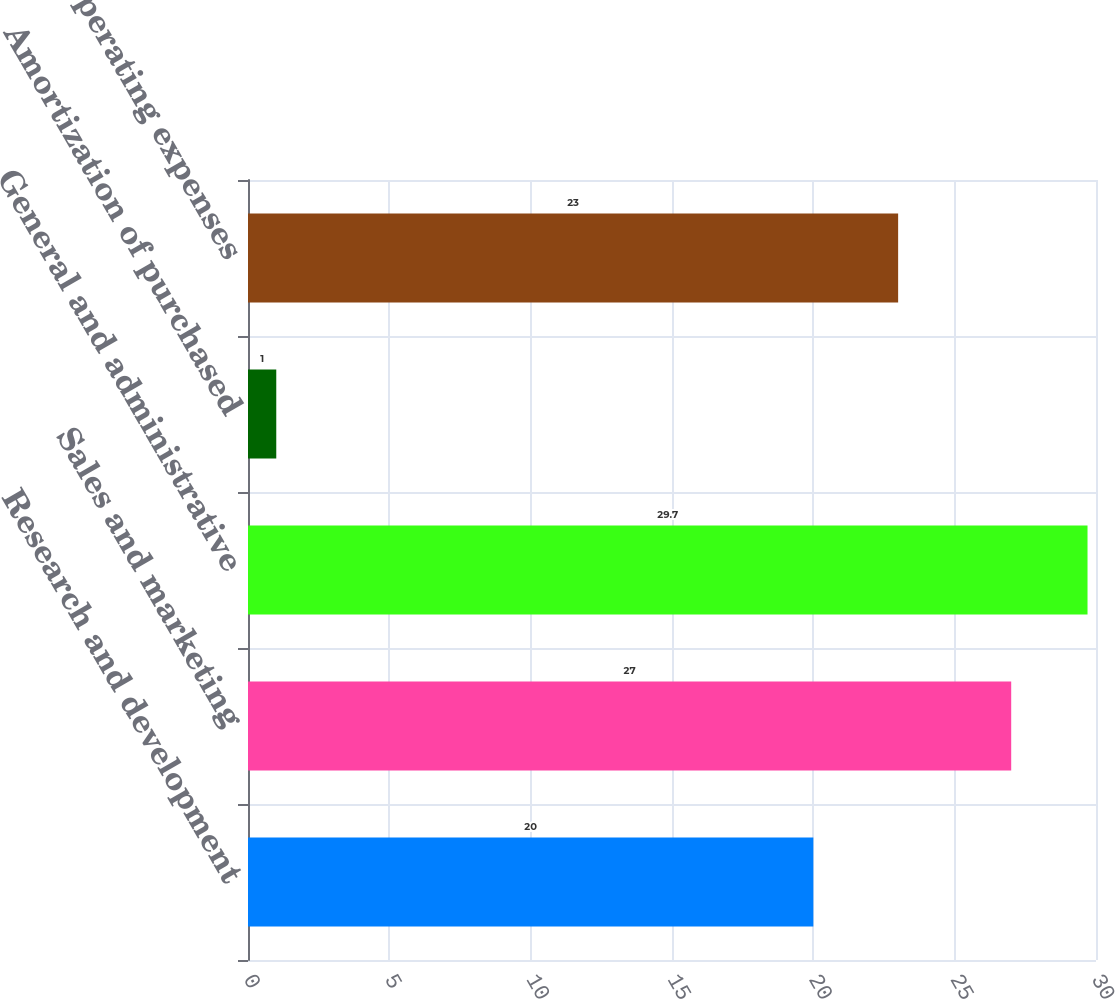<chart> <loc_0><loc_0><loc_500><loc_500><bar_chart><fcel>Research and development<fcel>Sales and marketing<fcel>General and administrative<fcel>Amortization of purchased<fcel>Total operating expenses<nl><fcel>20<fcel>27<fcel>29.7<fcel>1<fcel>23<nl></chart> 